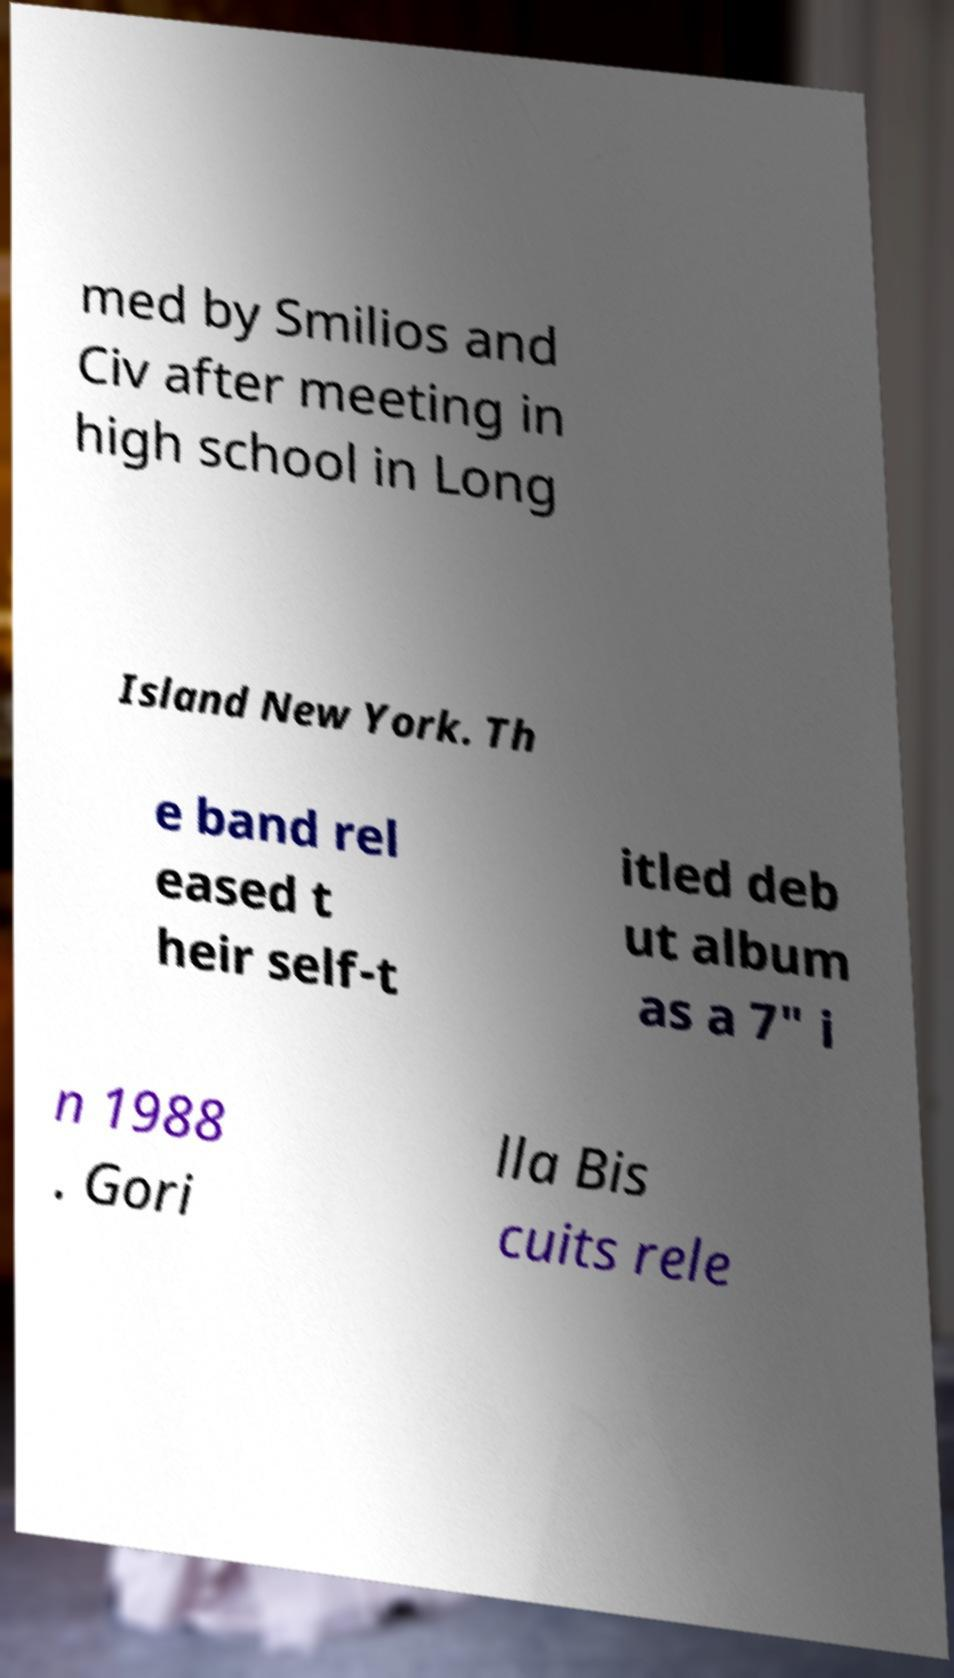What messages or text are displayed in this image? I need them in a readable, typed format. med by Smilios and Civ after meeting in high school in Long Island New York. Th e band rel eased t heir self-t itled deb ut album as a 7" i n 1988 . Gori lla Bis cuits rele 